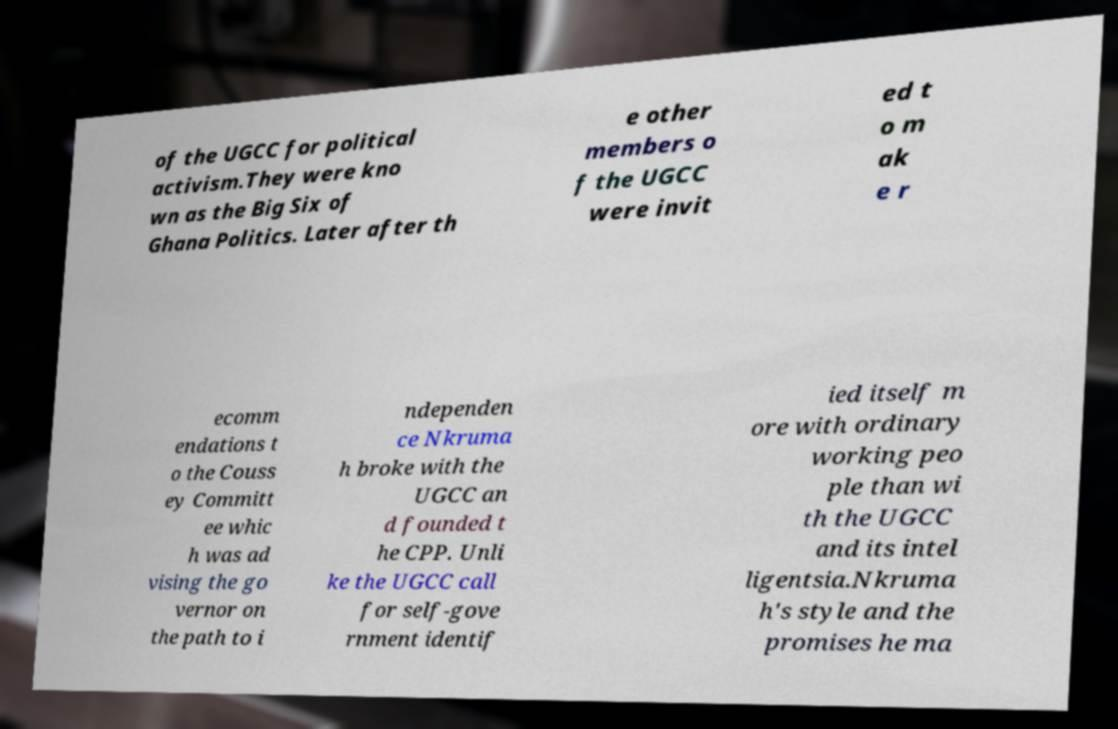I need the written content from this picture converted into text. Can you do that? of the UGCC for political activism.They were kno wn as the Big Six of Ghana Politics. Later after th e other members o f the UGCC were invit ed t o m ak e r ecomm endations t o the Couss ey Committ ee whic h was ad vising the go vernor on the path to i ndependen ce Nkruma h broke with the UGCC an d founded t he CPP. Unli ke the UGCC call for self-gove rnment identif ied itself m ore with ordinary working peo ple than wi th the UGCC and its intel ligentsia.Nkruma h's style and the promises he ma 